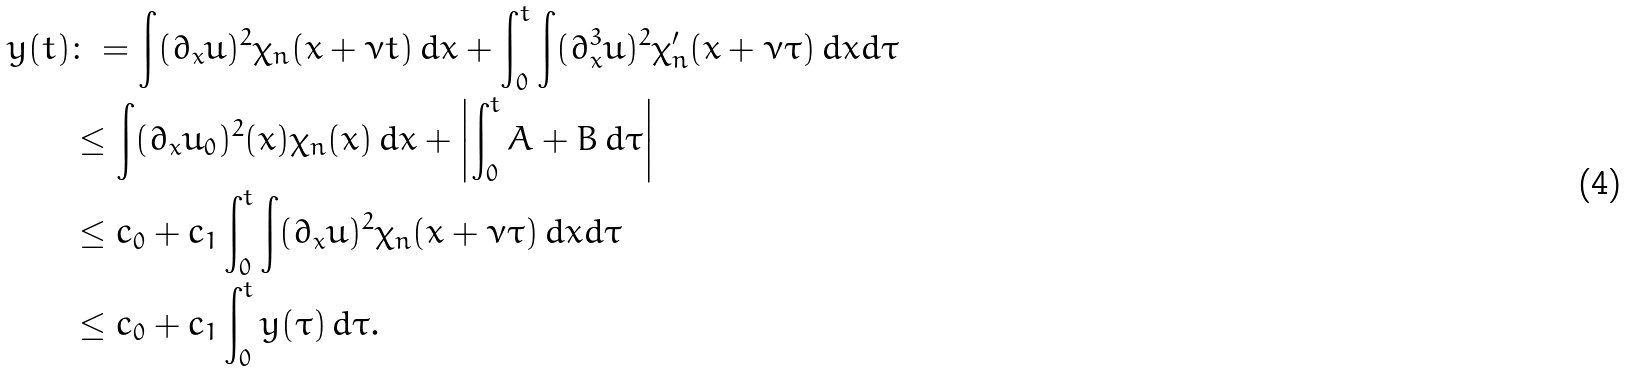<formula> <loc_0><loc_0><loc_500><loc_500>y ( t ) & \colon = \int ( \partial _ { x } u ) ^ { 2 } \chi _ { n } ( x + \nu t ) \, d x + \int _ { 0 } ^ { t } \int ( \partial _ { x } ^ { 3 } u ) ^ { 2 } \chi _ { n } ^ { \prime } ( x + \nu \tau ) \, d x d \tau \\ & \leq \int ( \partial _ { x } u _ { 0 } ) ^ { 2 } ( x ) \chi _ { n } ( x ) \, d x + \left | \int _ { 0 } ^ { t } A + B \, d \tau \right | \\ & \leq c _ { 0 } + c _ { 1 } \int _ { 0 } ^ { t } \int ( \partial _ { x } u ) ^ { 2 } \chi _ { n } ( x + \nu \tau ) \, d x d \tau \\ & \leq c _ { 0 } + c _ { 1 } \int _ { 0 } ^ { t } y ( \tau ) \, d \tau .</formula> 